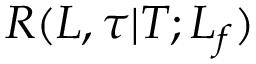<formula> <loc_0><loc_0><loc_500><loc_500>R ( L , \tau | T ; L _ { f } )</formula> 